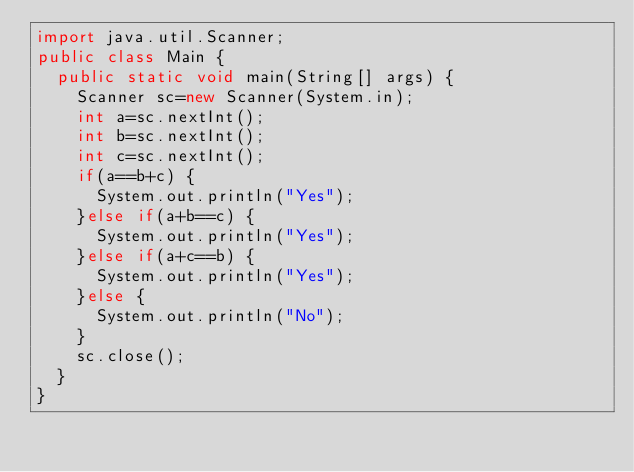Convert code to text. <code><loc_0><loc_0><loc_500><loc_500><_Java_>import java.util.Scanner;
public class Main {
	public static void main(String[] args) {
		Scanner sc=new Scanner(System.in);
		int a=sc.nextInt();
		int b=sc.nextInt();
		int c=sc.nextInt();
		if(a==b+c) {
			System.out.println("Yes");
		}else if(a+b==c) {
			System.out.println("Yes");
		}else if(a+c==b) {
			System.out.println("Yes");
		}else {
			System.out.println("No");
		}
		sc.close();
	}
}</code> 